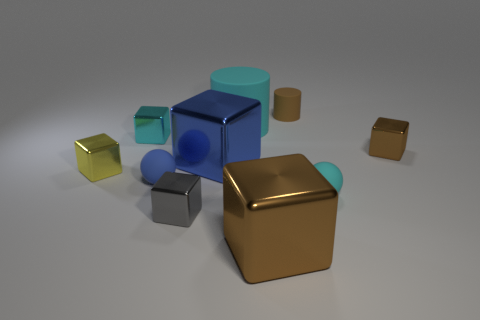Subtract all large brown metal cubes. How many cubes are left? 5 Subtract all yellow cubes. How many cubes are left? 5 Subtract 1 cubes. How many cubes are left? 5 Subtract all purple cubes. Subtract all cyan balls. How many cubes are left? 6 Subtract all spheres. How many objects are left? 8 Subtract 0 yellow balls. How many objects are left? 10 Subtract all big brown cylinders. Subtract all rubber balls. How many objects are left? 8 Add 1 brown metallic things. How many brown metallic things are left? 3 Add 5 brown objects. How many brown objects exist? 8 